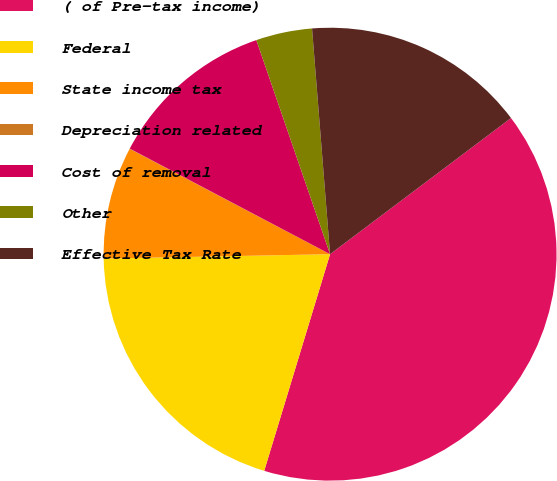Convert chart to OTSL. <chart><loc_0><loc_0><loc_500><loc_500><pie_chart><fcel>( of Pre-tax income)<fcel>Federal<fcel>State income tax<fcel>Depreciation related<fcel>Cost of removal<fcel>Other<fcel>Effective Tax Rate<nl><fcel>39.96%<fcel>19.99%<fcel>8.01%<fcel>0.02%<fcel>12.0%<fcel>4.01%<fcel>16.0%<nl></chart> 